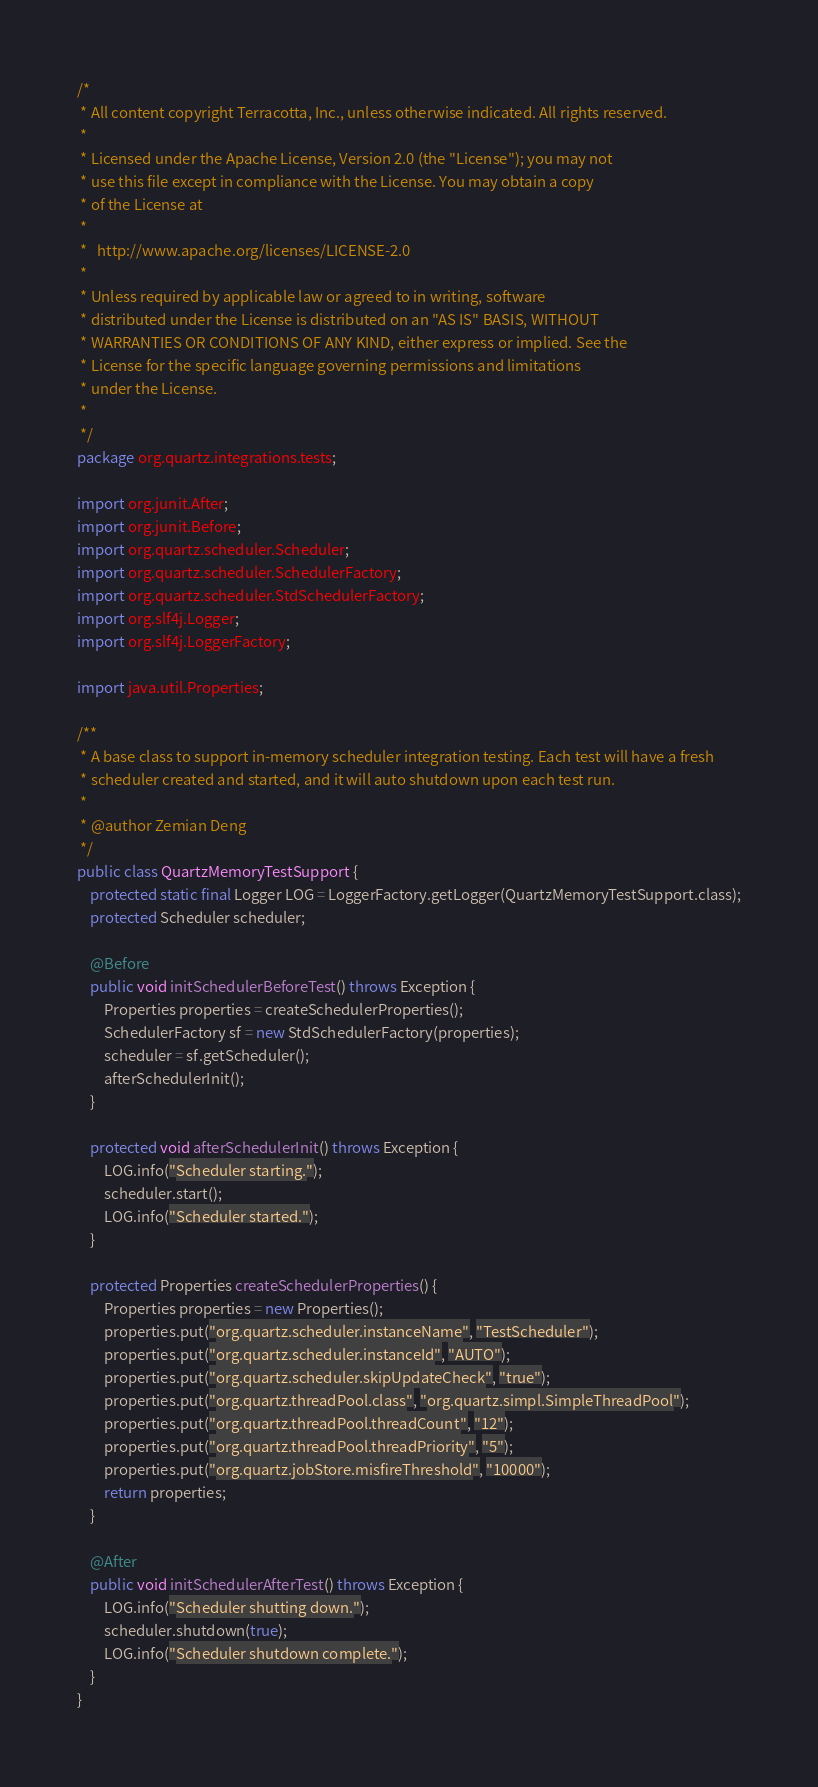Convert code to text. <code><loc_0><loc_0><loc_500><loc_500><_Java_>/*
 * All content copyright Terracotta, Inc., unless otherwise indicated. All rights reserved.
 *
 * Licensed under the Apache License, Version 2.0 (the "License"); you may not
 * use this file except in compliance with the License. You may obtain a copy
 * of the License at
 *
 *   http://www.apache.org/licenses/LICENSE-2.0
 *
 * Unless required by applicable law or agreed to in writing, software
 * distributed under the License is distributed on an "AS IS" BASIS, WITHOUT
 * WARRANTIES OR CONDITIONS OF ANY KIND, either express or implied. See the
 * License for the specific language governing permissions and limitations
 * under the License.
 *
 */
package org.quartz.integrations.tests;

import org.junit.After;
import org.junit.Before;
import org.quartz.scheduler.Scheduler;
import org.quartz.scheduler.SchedulerFactory;
import org.quartz.scheduler.StdSchedulerFactory;
import org.slf4j.Logger;
import org.slf4j.LoggerFactory;

import java.util.Properties;

/**
 * A base class to support in-memory scheduler integration testing. Each test will have a fresh
 * scheduler created and started, and it will auto shutdown upon each test run.
 *
 * @author Zemian Deng
 */
public class QuartzMemoryTestSupport {
    protected static final Logger LOG = LoggerFactory.getLogger(QuartzMemoryTestSupport.class);
    protected Scheduler scheduler;

    @Before
    public void initSchedulerBeforeTest() throws Exception {
        Properties properties = createSchedulerProperties();
        SchedulerFactory sf = new StdSchedulerFactory(properties);
        scheduler = sf.getScheduler();
        afterSchedulerInit();
    }

    protected void afterSchedulerInit() throws Exception {
        LOG.info("Scheduler starting.");
        scheduler.start();
        LOG.info("Scheduler started.");
    }

    protected Properties createSchedulerProperties() {
        Properties properties = new Properties();
        properties.put("org.quartz.scheduler.instanceName", "TestScheduler");
        properties.put("org.quartz.scheduler.instanceId", "AUTO");
        properties.put("org.quartz.scheduler.skipUpdateCheck", "true");
        properties.put("org.quartz.threadPool.class", "org.quartz.simpl.SimpleThreadPool");
        properties.put("org.quartz.threadPool.threadCount", "12");
        properties.put("org.quartz.threadPool.threadPriority", "5");
        properties.put("org.quartz.jobStore.misfireThreshold", "10000");
        return properties;
    }

    @After
    public void initSchedulerAfterTest() throws Exception {
        LOG.info("Scheduler shutting down.");
        scheduler.shutdown(true);
        LOG.info("Scheduler shutdown complete.");
    }
}
</code> 